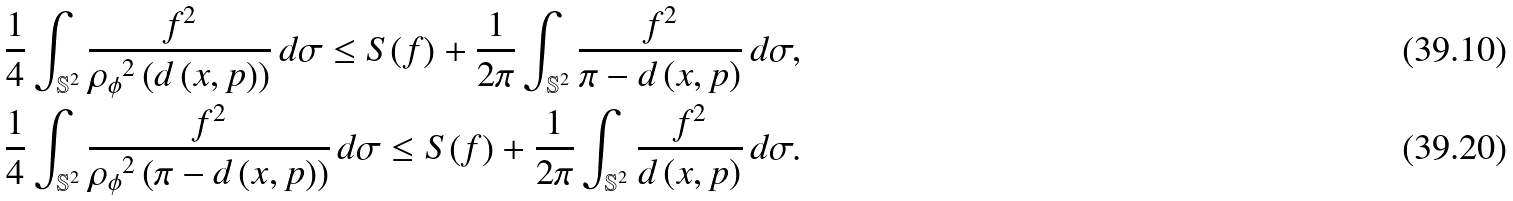Convert formula to latex. <formula><loc_0><loc_0><loc_500><loc_500>& \frac { 1 } { 4 } \int _ { \mathbb { S } ^ { 2 } } \frac { f ^ { 2 } } { { { \rho } _ { \phi } } ^ { 2 } \left ( d \left ( x , p \right ) \right ) } \, d \sigma \leq S ( f ) + \frac { 1 } { 2 \pi } \int _ { \mathbb { S } ^ { 2 } } \frac { f ^ { 2 } } { \pi - d \left ( x , p \right ) } \, d \sigma , \\ & \frac { 1 } { 4 } \int _ { \mathbb { S } ^ { 2 } } \frac { f ^ { 2 } } { { { \rho } _ { \phi } } ^ { 2 } \left ( \pi - d \left ( x , p \right ) \right ) } \, d \sigma \leq S ( f ) + \frac { 1 } { 2 \pi } \int _ { \mathbb { S } ^ { 2 } } \frac { f ^ { 2 } } { d \left ( x , p \right ) } \, d \sigma .</formula> 